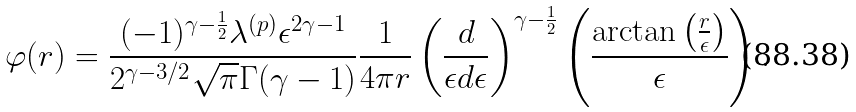<formula> <loc_0><loc_0><loc_500><loc_500>\varphi ( r ) = \frac { ( - 1 ) ^ { \gamma - \frac { 1 } { 2 } } \lambda ^ { ( p ) } \epsilon ^ { 2 \gamma - 1 } } { 2 ^ { \gamma - 3 / 2 } \sqrt { \pi } \Gamma ( \gamma - 1 ) } \frac { 1 } { 4 \pi r } \left ( \frac { d } { \epsilon d \epsilon } \right ) ^ { \gamma - \frac { 1 } { 2 } } \left ( \frac { \arctan \left ( \frac { r } { \epsilon } \right ) } { \epsilon } \right ) .</formula> 